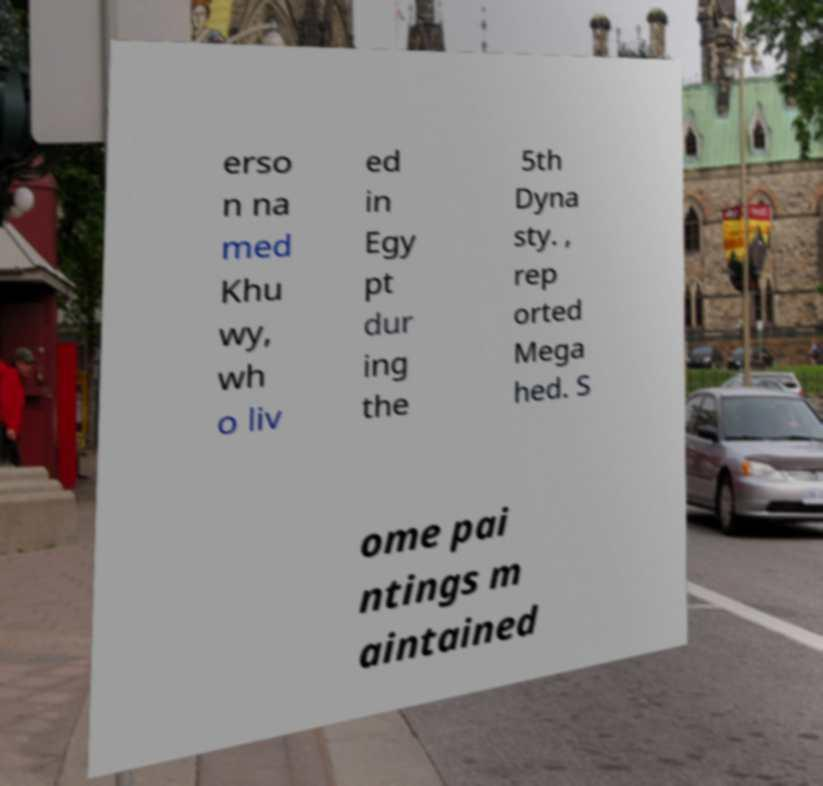Could you extract and type out the text from this image? erso n na med Khu wy, wh o liv ed in Egy pt dur ing the 5th Dyna sty. , rep orted Mega hed. S ome pai ntings m aintained 